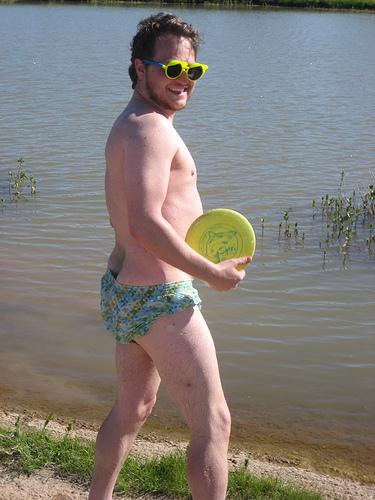What is the man wearing?
Keep it brief. Swim trunks. What is in the man's hand?
Answer briefly. Frisbee. Where is the man?
Concise answer only. Beach. Where does the come up to on this man's body?
Be succinct. Waist. 